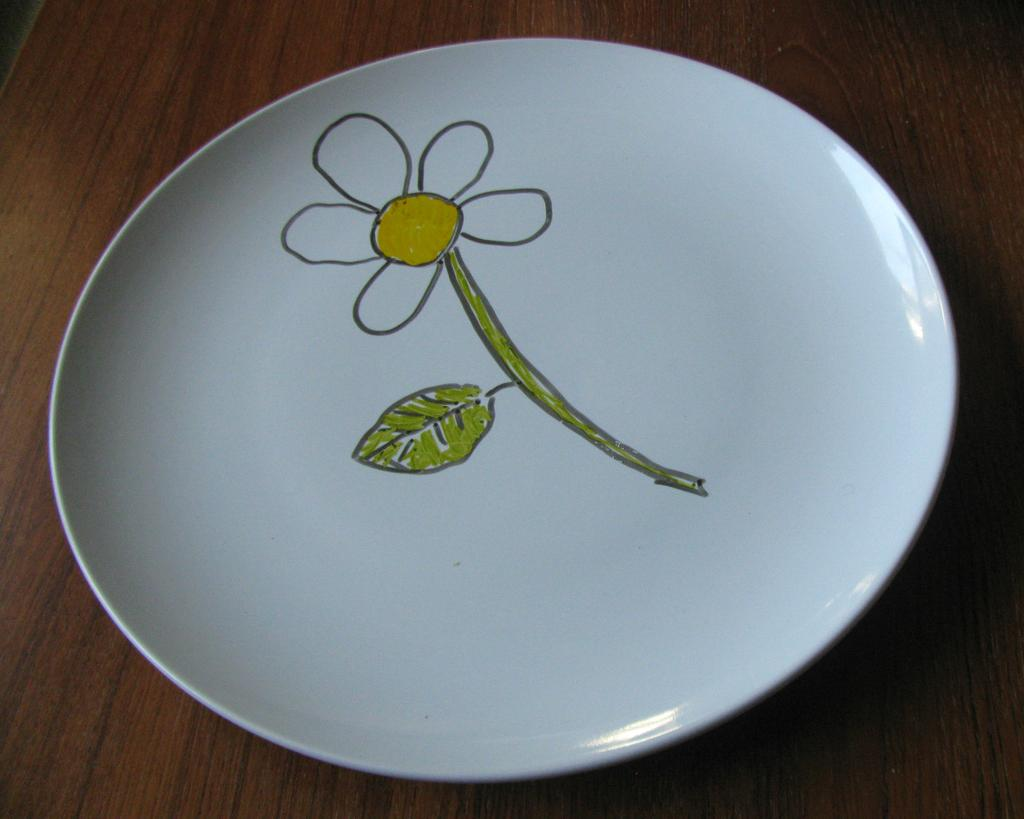What is depicted on the plate in the image? There is a drawing of a flower on a plate in the image. What color is the plate? The plate is white. On what surface is the plate placed? The plate is placed on a wooden object. What type of rice is being served on the stage in the image? There is no rice or stage present in the image; it features a drawing of a flower on a white plate placed on a wooden object. 